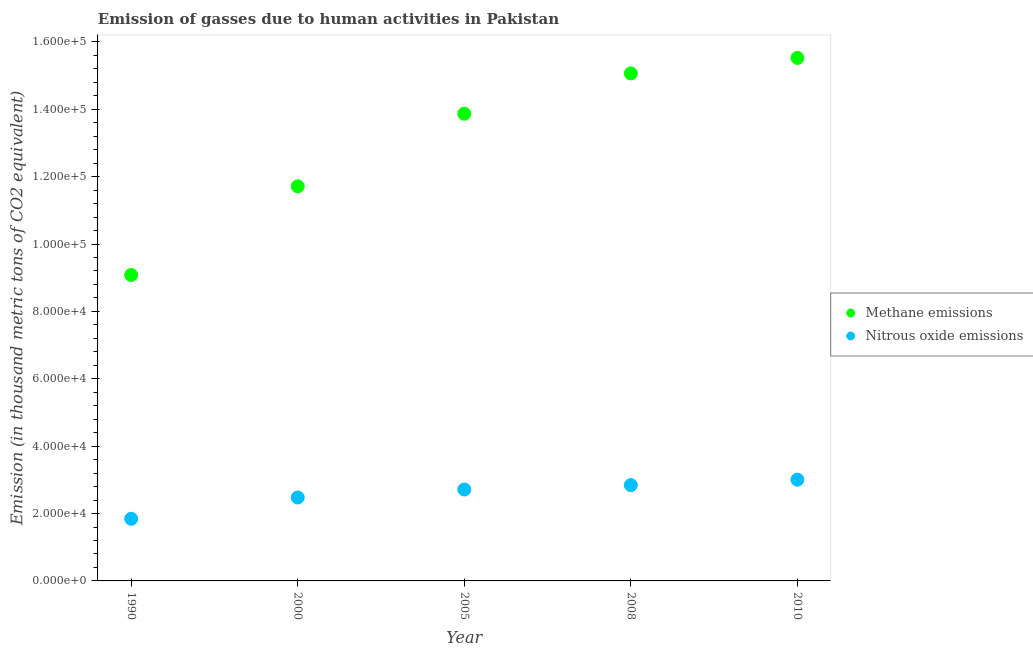Is the number of dotlines equal to the number of legend labels?
Keep it short and to the point. Yes. What is the amount of methane emissions in 2010?
Ensure brevity in your answer.  1.55e+05. Across all years, what is the maximum amount of nitrous oxide emissions?
Your answer should be very brief. 3.01e+04. Across all years, what is the minimum amount of methane emissions?
Provide a short and direct response. 9.08e+04. What is the total amount of nitrous oxide emissions in the graph?
Provide a short and direct response. 1.29e+05. What is the difference between the amount of nitrous oxide emissions in 2000 and that in 2005?
Your answer should be very brief. -2374.8. What is the difference between the amount of methane emissions in 2010 and the amount of nitrous oxide emissions in 2000?
Your answer should be compact. 1.30e+05. What is the average amount of methane emissions per year?
Your answer should be very brief. 1.30e+05. In the year 2008, what is the difference between the amount of methane emissions and amount of nitrous oxide emissions?
Your answer should be compact. 1.22e+05. What is the ratio of the amount of nitrous oxide emissions in 2005 to that in 2008?
Your answer should be very brief. 0.95. Is the difference between the amount of methane emissions in 1990 and 2000 greater than the difference between the amount of nitrous oxide emissions in 1990 and 2000?
Your response must be concise. No. What is the difference between the highest and the second highest amount of methane emissions?
Keep it short and to the point. 4592.5. What is the difference between the highest and the lowest amount of nitrous oxide emissions?
Make the answer very short. 1.16e+04. In how many years, is the amount of nitrous oxide emissions greater than the average amount of nitrous oxide emissions taken over all years?
Keep it short and to the point. 3. Does the amount of methane emissions monotonically increase over the years?
Your answer should be compact. Yes. How many years are there in the graph?
Keep it short and to the point. 5. What is the difference between two consecutive major ticks on the Y-axis?
Offer a very short reply. 2.00e+04. Are the values on the major ticks of Y-axis written in scientific E-notation?
Offer a very short reply. Yes. How many legend labels are there?
Your response must be concise. 2. How are the legend labels stacked?
Ensure brevity in your answer.  Vertical. What is the title of the graph?
Give a very brief answer. Emission of gasses due to human activities in Pakistan. Does "constant 2005 US$" appear as one of the legend labels in the graph?
Offer a very short reply. No. What is the label or title of the X-axis?
Ensure brevity in your answer.  Year. What is the label or title of the Y-axis?
Offer a very short reply. Emission (in thousand metric tons of CO2 equivalent). What is the Emission (in thousand metric tons of CO2 equivalent) in Methane emissions in 1990?
Provide a succinct answer. 9.08e+04. What is the Emission (in thousand metric tons of CO2 equivalent) in Nitrous oxide emissions in 1990?
Offer a terse response. 1.84e+04. What is the Emission (in thousand metric tons of CO2 equivalent) of Methane emissions in 2000?
Provide a short and direct response. 1.17e+05. What is the Emission (in thousand metric tons of CO2 equivalent) of Nitrous oxide emissions in 2000?
Offer a very short reply. 2.48e+04. What is the Emission (in thousand metric tons of CO2 equivalent) in Methane emissions in 2005?
Your answer should be compact. 1.39e+05. What is the Emission (in thousand metric tons of CO2 equivalent) in Nitrous oxide emissions in 2005?
Your response must be concise. 2.71e+04. What is the Emission (in thousand metric tons of CO2 equivalent) of Methane emissions in 2008?
Provide a succinct answer. 1.51e+05. What is the Emission (in thousand metric tons of CO2 equivalent) of Nitrous oxide emissions in 2008?
Offer a very short reply. 2.84e+04. What is the Emission (in thousand metric tons of CO2 equivalent) in Methane emissions in 2010?
Ensure brevity in your answer.  1.55e+05. What is the Emission (in thousand metric tons of CO2 equivalent) of Nitrous oxide emissions in 2010?
Provide a succinct answer. 3.01e+04. Across all years, what is the maximum Emission (in thousand metric tons of CO2 equivalent) of Methane emissions?
Your answer should be compact. 1.55e+05. Across all years, what is the maximum Emission (in thousand metric tons of CO2 equivalent) in Nitrous oxide emissions?
Your answer should be very brief. 3.01e+04. Across all years, what is the minimum Emission (in thousand metric tons of CO2 equivalent) of Methane emissions?
Keep it short and to the point. 9.08e+04. Across all years, what is the minimum Emission (in thousand metric tons of CO2 equivalent) in Nitrous oxide emissions?
Ensure brevity in your answer.  1.84e+04. What is the total Emission (in thousand metric tons of CO2 equivalent) in Methane emissions in the graph?
Provide a succinct answer. 6.52e+05. What is the total Emission (in thousand metric tons of CO2 equivalent) in Nitrous oxide emissions in the graph?
Give a very brief answer. 1.29e+05. What is the difference between the Emission (in thousand metric tons of CO2 equivalent) in Methane emissions in 1990 and that in 2000?
Your answer should be very brief. -2.63e+04. What is the difference between the Emission (in thousand metric tons of CO2 equivalent) of Nitrous oxide emissions in 1990 and that in 2000?
Your answer should be very brief. -6318. What is the difference between the Emission (in thousand metric tons of CO2 equivalent) of Methane emissions in 1990 and that in 2005?
Offer a very short reply. -4.79e+04. What is the difference between the Emission (in thousand metric tons of CO2 equivalent) in Nitrous oxide emissions in 1990 and that in 2005?
Your answer should be compact. -8692.8. What is the difference between the Emission (in thousand metric tons of CO2 equivalent) in Methane emissions in 1990 and that in 2008?
Ensure brevity in your answer.  -5.98e+04. What is the difference between the Emission (in thousand metric tons of CO2 equivalent) of Nitrous oxide emissions in 1990 and that in 2008?
Your answer should be compact. -9991.4. What is the difference between the Emission (in thousand metric tons of CO2 equivalent) in Methane emissions in 1990 and that in 2010?
Give a very brief answer. -6.44e+04. What is the difference between the Emission (in thousand metric tons of CO2 equivalent) in Nitrous oxide emissions in 1990 and that in 2010?
Provide a succinct answer. -1.16e+04. What is the difference between the Emission (in thousand metric tons of CO2 equivalent) of Methane emissions in 2000 and that in 2005?
Your answer should be compact. -2.15e+04. What is the difference between the Emission (in thousand metric tons of CO2 equivalent) of Nitrous oxide emissions in 2000 and that in 2005?
Give a very brief answer. -2374.8. What is the difference between the Emission (in thousand metric tons of CO2 equivalent) in Methane emissions in 2000 and that in 2008?
Make the answer very short. -3.35e+04. What is the difference between the Emission (in thousand metric tons of CO2 equivalent) of Nitrous oxide emissions in 2000 and that in 2008?
Your response must be concise. -3673.4. What is the difference between the Emission (in thousand metric tons of CO2 equivalent) of Methane emissions in 2000 and that in 2010?
Keep it short and to the point. -3.81e+04. What is the difference between the Emission (in thousand metric tons of CO2 equivalent) in Nitrous oxide emissions in 2000 and that in 2010?
Offer a terse response. -5290.5. What is the difference between the Emission (in thousand metric tons of CO2 equivalent) of Methane emissions in 2005 and that in 2008?
Offer a terse response. -1.20e+04. What is the difference between the Emission (in thousand metric tons of CO2 equivalent) in Nitrous oxide emissions in 2005 and that in 2008?
Provide a short and direct response. -1298.6. What is the difference between the Emission (in thousand metric tons of CO2 equivalent) in Methane emissions in 2005 and that in 2010?
Ensure brevity in your answer.  -1.66e+04. What is the difference between the Emission (in thousand metric tons of CO2 equivalent) in Nitrous oxide emissions in 2005 and that in 2010?
Provide a short and direct response. -2915.7. What is the difference between the Emission (in thousand metric tons of CO2 equivalent) in Methane emissions in 2008 and that in 2010?
Your response must be concise. -4592.5. What is the difference between the Emission (in thousand metric tons of CO2 equivalent) in Nitrous oxide emissions in 2008 and that in 2010?
Make the answer very short. -1617.1. What is the difference between the Emission (in thousand metric tons of CO2 equivalent) of Methane emissions in 1990 and the Emission (in thousand metric tons of CO2 equivalent) of Nitrous oxide emissions in 2000?
Your answer should be compact. 6.60e+04. What is the difference between the Emission (in thousand metric tons of CO2 equivalent) of Methane emissions in 1990 and the Emission (in thousand metric tons of CO2 equivalent) of Nitrous oxide emissions in 2005?
Provide a short and direct response. 6.37e+04. What is the difference between the Emission (in thousand metric tons of CO2 equivalent) of Methane emissions in 1990 and the Emission (in thousand metric tons of CO2 equivalent) of Nitrous oxide emissions in 2008?
Provide a short and direct response. 6.24e+04. What is the difference between the Emission (in thousand metric tons of CO2 equivalent) of Methane emissions in 1990 and the Emission (in thousand metric tons of CO2 equivalent) of Nitrous oxide emissions in 2010?
Make the answer very short. 6.08e+04. What is the difference between the Emission (in thousand metric tons of CO2 equivalent) in Methane emissions in 2000 and the Emission (in thousand metric tons of CO2 equivalent) in Nitrous oxide emissions in 2005?
Provide a short and direct response. 9.00e+04. What is the difference between the Emission (in thousand metric tons of CO2 equivalent) of Methane emissions in 2000 and the Emission (in thousand metric tons of CO2 equivalent) of Nitrous oxide emissions in 2008?
Provide a succinct answer. 8.87e+04. What is the difference between the Emission (in thousand metric tons of CO2 equivalent) in Methane emissions in 2000 and the Emission (in thousand metric tons of CO2 equivalent) in Nitrous oxide emissions in 2010?
Provide a succinct answer. 8.71e+04. What is the difference between the Emission (in thousand metric tons of CO2 equivalent) in Methane emissions in 2005 and the Emission (in thousand metric tons of CO2 equivalent) in Nitrous oxide emissions in 2008?
Offer a very short reply. 1.10e+05. What is the difference between the Emission (in thousand metric tons of CO2 equivalent) in Methane emissions in 2005 and the Emission (in thousand metric tons of CO2 equivalent) in Nitrous oxide emissions in 2010?
Your response must be concise. 1.09e+05. What is the difference between the Emission (in thousand metric tons of CO2 equivalent) in Methane emissions in 2008 and the Emission (in thousand metric tons of CO2 equivalent) in Nitrous oxide emissions in 2010?
Provide a succinct answer. 1.21e+05. What is the average Emission (in thousand metric tons of CO2 equivalent) of Methane emissions per year?
Ensure brevity in your answer.  1.30e+05. What is the average Emission (in thousand metric tons of CO2 equivalent) of Nitrous oxide emissions per year?
Give a very brief answer. 2.58e+04. In the year 1990, what is the difference between the Emission (in thousand metric tons of CO2 equivalent) in Methane emissions and Emission (in thousand metric tons of CO2 equivalent) in Nitrous oxide emissions?
Offer a very short reply. 7.24e+04. In the year 2000, what is the difference between the Emission (in thousand metric tons of CO2 equivalent) of Methane emissions and Emission (in thousand metric tons of CO2 equivalent) of Nitrous oxide emissions?
Ensure brevity in your answer.  9.24e+04. In the year 2005, what is the difference between the Emission (in thousand metric tons of CO2 equivalent) of Methane emissions and Emission (in thousand metric tons of CO2 equivalent) of Nitrous oxide emissions?
Your answer should be very brief. 1.12e+05. In the year 2008, what is the difference between the Emission (in thousand metric tons of CO2 equivalent) in Methane emissions and Emission (in thousand metric tons of CO2 equivalent) in Nitrous oxide emissions?
Provide a short and direct response. 1.22e+05. In the year 2010, what is the difference between the Emission (in thousand metric tons of CO2 equivalent) in Methane emissions and Emission (in thousand metric tons of CO2 equivalent) in Nitrous oxide emissions?
Provide a short and direct response. 1.25e+05. What is the ratio of the Emission (in thousand metric tons of CO2 equivalent) in Methane emissions in 1990 to that in 2000?
Provide a short and direct response. 0.78. What is the ratio of the Emission (in thousand metric tons of CO2 equivalent) in Nitrous oxide emissions in 1990 to that in 2000?
Provide a short and direct response. 0.74. What is the ratio of the Emission (in thousand metric tons of CO2 equivalent) of Methane emissions in 1990 to that in 2005?
Keep it short and to the point. 0.65. What is the ratio of the Emission (in thousand metric tons of CO2 equivalent) in Nitrous oxide emissions in 1990 to that in 2005?
Offer a terse response. 0.68. What is the ratio of the Emission (in thousand metric tons of CO2 equivalent) in Methane emissions in 1990 to that in 2008?
Ensure brevity in your answer.  0.6. What is the ratio of the Emission (in thousand metric tons of CO2 equivalent) in Nitrous oxide emissions in 1990 to that in 2008?
Your answer should be compact. 0.65. What is the ratio of the Emission (in thousand metric tons of CO2 equivalent) of Methane emissions in 1990 to that in 2010?
Provide a succinct answer. 0.58. What is the ratio of the Emission (in thousand metric tons of CO2 equivalent) of Nitrous oxide emissions in 1990 to that in 2010?
Your response must be concise. 0.61. What is the ratio of the Emission (in thousand metric tons of CO2 equivalent) of Methane emissions in 2000 to that in 2005?
Offer a terse response. 0.84. What is the ratio of the Emission (in thousand metric tons of CO2 equivalent) in Nitrous oxide emissions in 2000 to that in 2005?
Your answer should be very brief. 0.91. What is the ratio of the Emission (in thousand metric tons of CO2 equivalent) in Methane emissions in 2000 to that in 2008?
Your response must be concise. 0.78. What is the ratio of the Emission (in thousand metric tons of CO2 equivalent) of Nitrous oxide emissions in 2000 to that in 2008?
Ensure brevity in your answer.  0.87. What is the ratio of the Emission (in thousand metric tons of CO2 equivalent) in Methane emissions in 2000 to that in 2010?
Make the answer very short. 0.75. What is the ratio of the Emission (in thousand metric tons of CO2 equivalent) of Nitrous oxide emissions in 2000 to that in 2010?
Offer a terse response. 0.82. What is the ratio of the Emission (in thousand metric tons of CO2 equivalent) of Methane emissions in 2005 to that in 2008?
Ensure brevity in your answer.  0.92. What is the ratio of the Emission (in thousand metric tons of CO2 equivalent) of Nitrous oxide emissions in 2005 to that in 2008?
Your answer should be compact. 0.95. What is the ratio of the Emission (in thousand metric tons of CO2 equivalent) of Methane emissions in 2005 to that in 2010?
Provide a short and direct response. 0.89. What is the ratio of the Emission (in thousand metric tons of CO2 equivalent) of Nitrous oxide emissions in 2005 to that in 2010?
Offer a terse response. 0.9. What is the ratio of the Emission (in thousand metric tons of CO2 equivalent) of Methane emissions in 2008 to that in 2010?
Offer a very short reply. 0.97. What is the ratio of the Emission (in thousand metric tons of CO2 equivalent) in Nitrous oxide emissions in 2008 to that in 2010?
Make the answer very short. 0.95. What is the difference between the highest and the second highest Emission (in thousand metric tons of CO2 equivalent) of Methane emissions?
Offer a terse response. 4592.5. What is the difference between the highest and the second highest Emission (in thousand metric tons of CO2 equivalent) in Nitrous oxide emissions?
Offer a terse response. 1617.1. What is the difference between the highest and the lowest Emission (in thousand metric tons of CO2 equivalent) in Methane emissions?
Ensure brevity in your answer.  6.44e+04. What is the difference between the highest and the lowest Emission (in thousand metric tons of CO2 equivalent) of Nitrous oxide emissions?
Make the answer very short. 1.16e+04. 